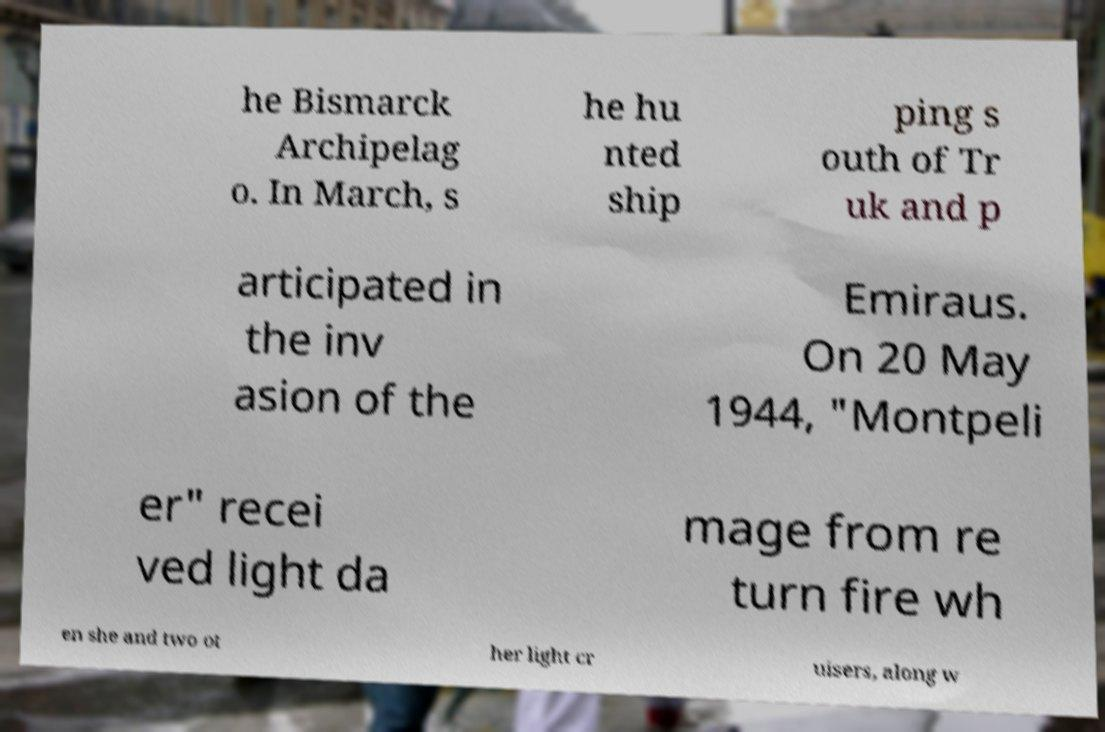I need the written content from this picture converted into text. Can you do that? he Bismarck Archipelag o. In March, s he hu nted ship ping s outh of Tr uk and p articipated in the inv asion of the Emiraus. On 20 May 1944, "Montpeli er" recei ved light da mage from re turn fire wh en she and two ot her light cr uisers, along w 